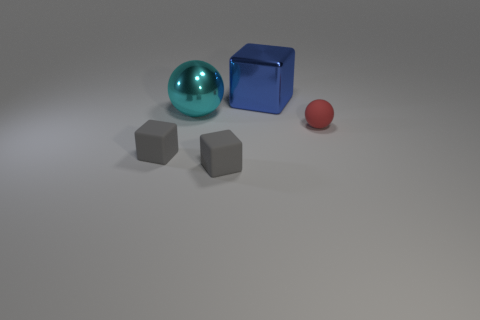Add 3 small brown metal blocks. How many objects exist? 8 Subtract all cubes. How many objects are left? 2 Add 3 red things. How many red things are left? 4 Add 4 yellow metallic blocks. How many yellow metallic blocks exist? 4 Subtract 0 yellow cylinders. How many objects are left? 5 Subtract all big red balls. Subtract all cyan metal things. How many objects are left? 4 